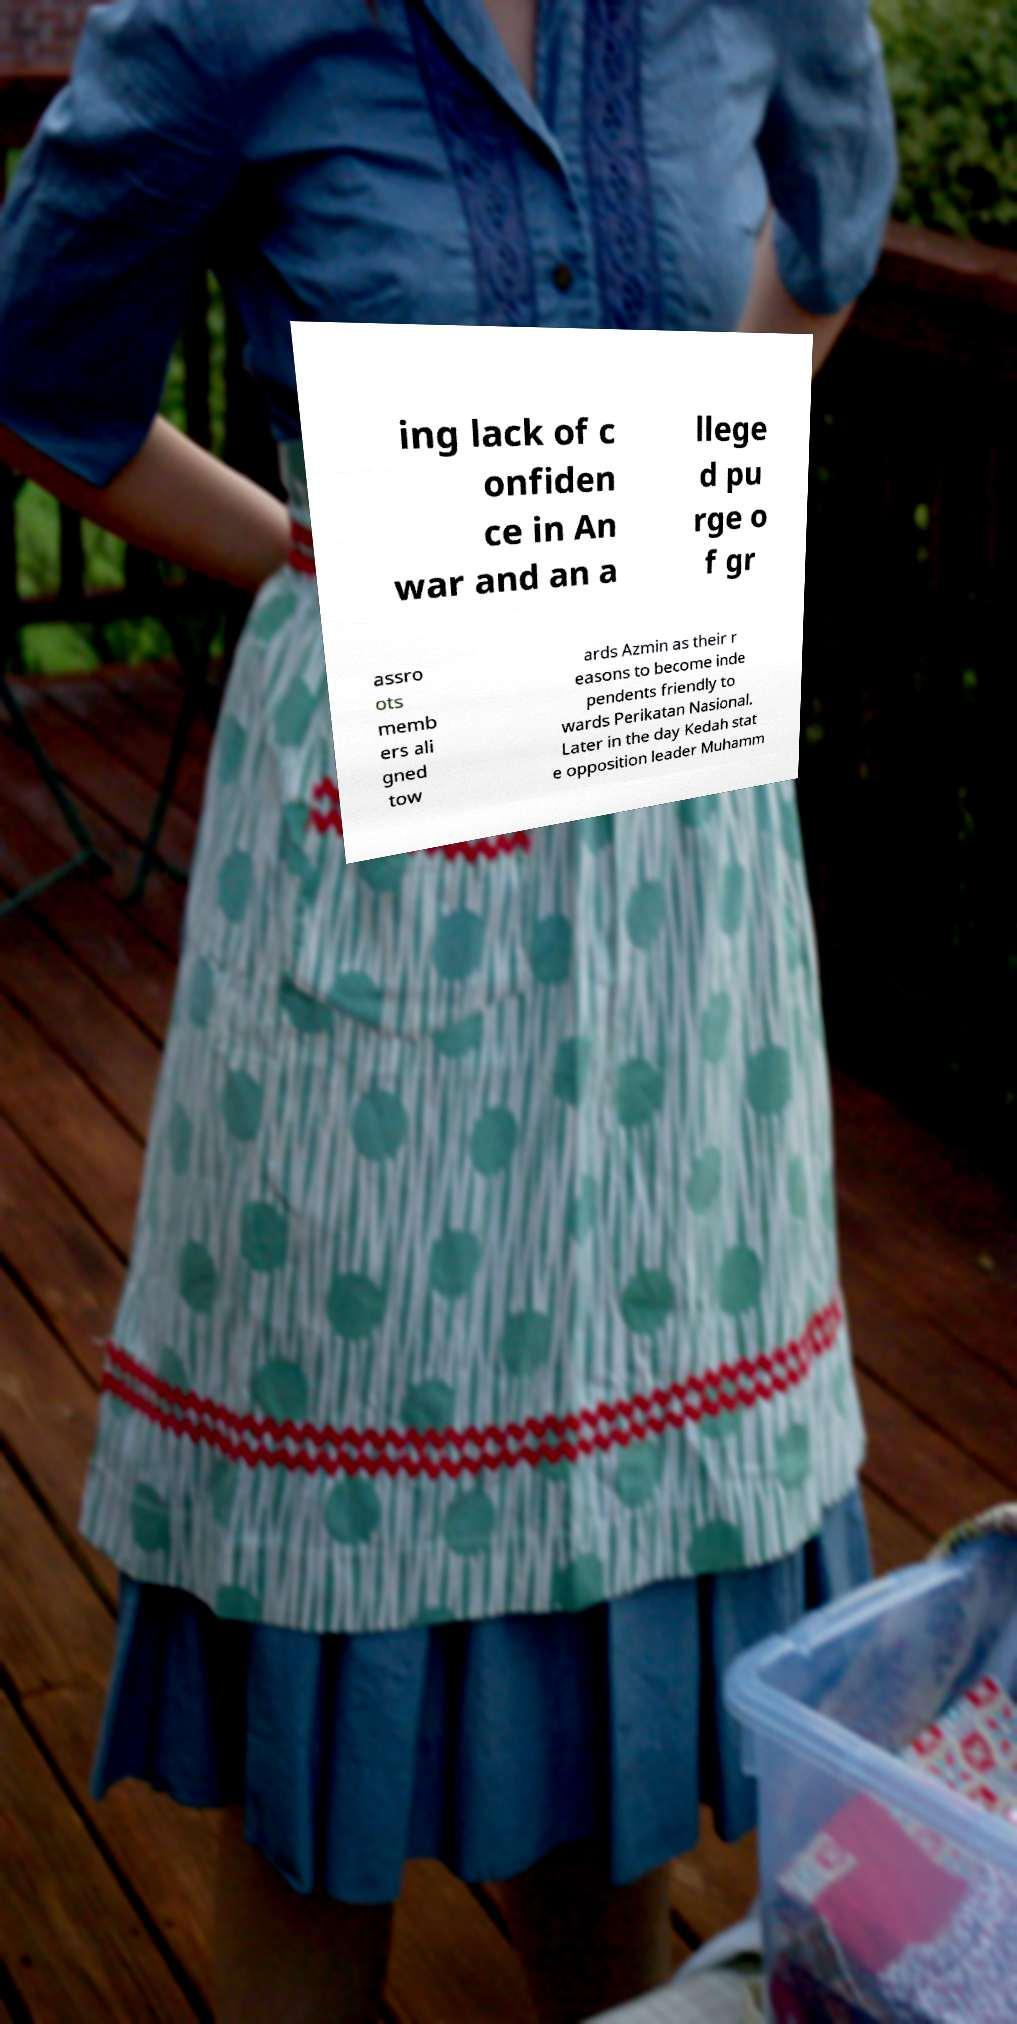Can you read and provide the text displayed in the image?This photo seems to have some interesting text. Can you extract and type it out for me? ing lack of c onfiden ce in An war and an a llege d pu rge o f gr assro ots memb ers ali gned tow ards Azmin as their r easons to become inde pendents friendly to wards Perikatan Nasional. Later in the day Kedah stat e opposition leader Muhamm 